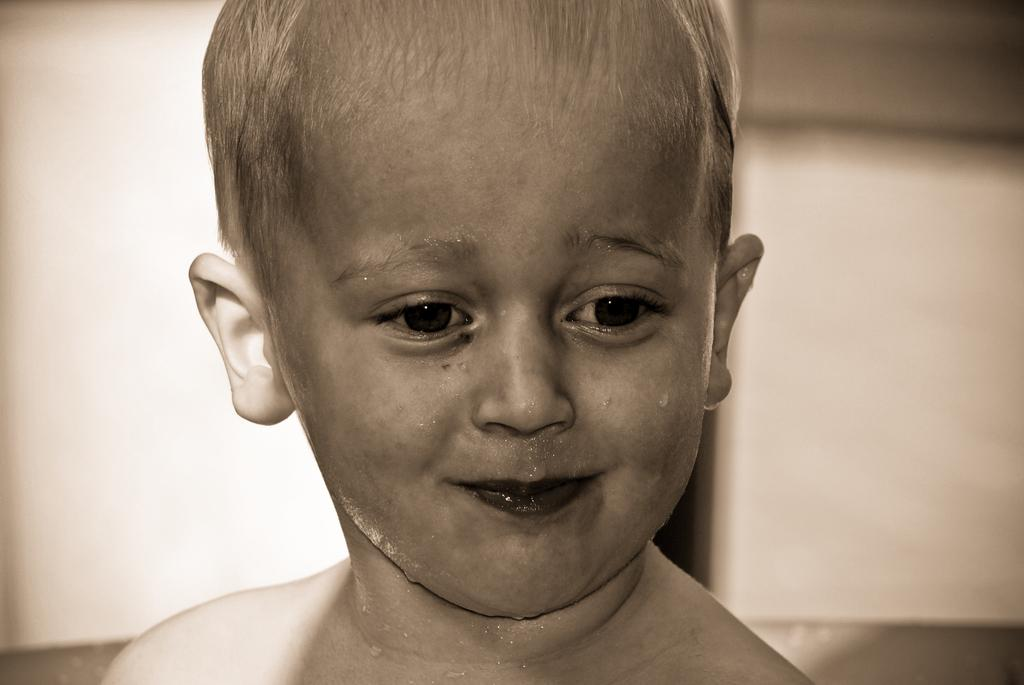Who is the main subject in the image? There is a boy in the image. What can be observed on the boy's face? There are water droplets on the boy's face. What color is the surface in the background of the image? The surface in the background of the image is white. How many laborers are working with the sheep in the image? There are no laborers or sheep present in the image; it features a boy with water droplets on his face and a white surface in the background. 